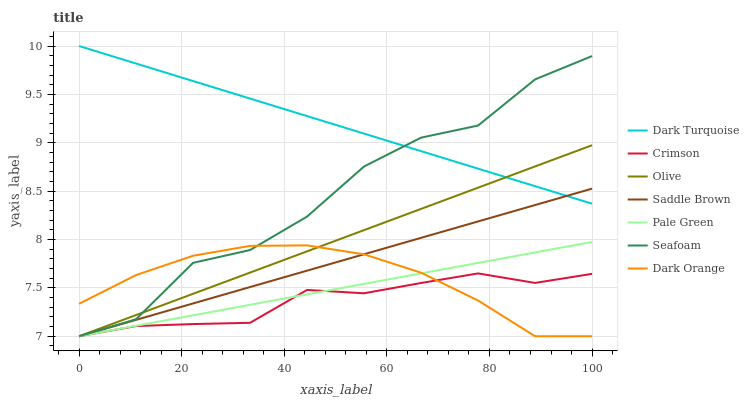Does Crimson have the minimum area under the curve?
Answer yes or no. Yes. Does Dark Turquoise have the maximum area under the curve?
Answer yes or no. Yes. Does Seafoam have the minimum area under the curve?
Answer yes or no. No. Does Seafoam have the maximum area under the curve?
Answer yes or no. No. Is Pale Green the smoothest?
Answer yes or no. Yes. Is Seafoam the roughest?
Answer yes or no. Yes. Is Dark Turquoise the smoothest?
Answer yes or no. No. Is Dark Turquoise the roughest?
Answer yes or no. No. Does Dark Orange have the lowest value?
Answer yes or no. Yes. Does Dark Turquoise have the lowest value?
Answer yes or no. No. Does Dark Turquoise have the highest value?
Answer yes or no. Yes. Does Seafoam have the highest value?
Answer yes or no. No. Is Crimson less than Dark Turquoise?
Answer yes or no. Yes. Is Dark Turquoise greater than Crimson?
Answer yes or no. Yes. Does Crimson intersect Saddle Brown?
Answer yes or no. Yes. Is Crimson less than Saddle Brown?
Answer yes or no. No. Is Crimson greater than Saddle Brown?
Answer yes or no. No. Does Crimson intersect Dark Turquoise?
Answer yes or no. No. 